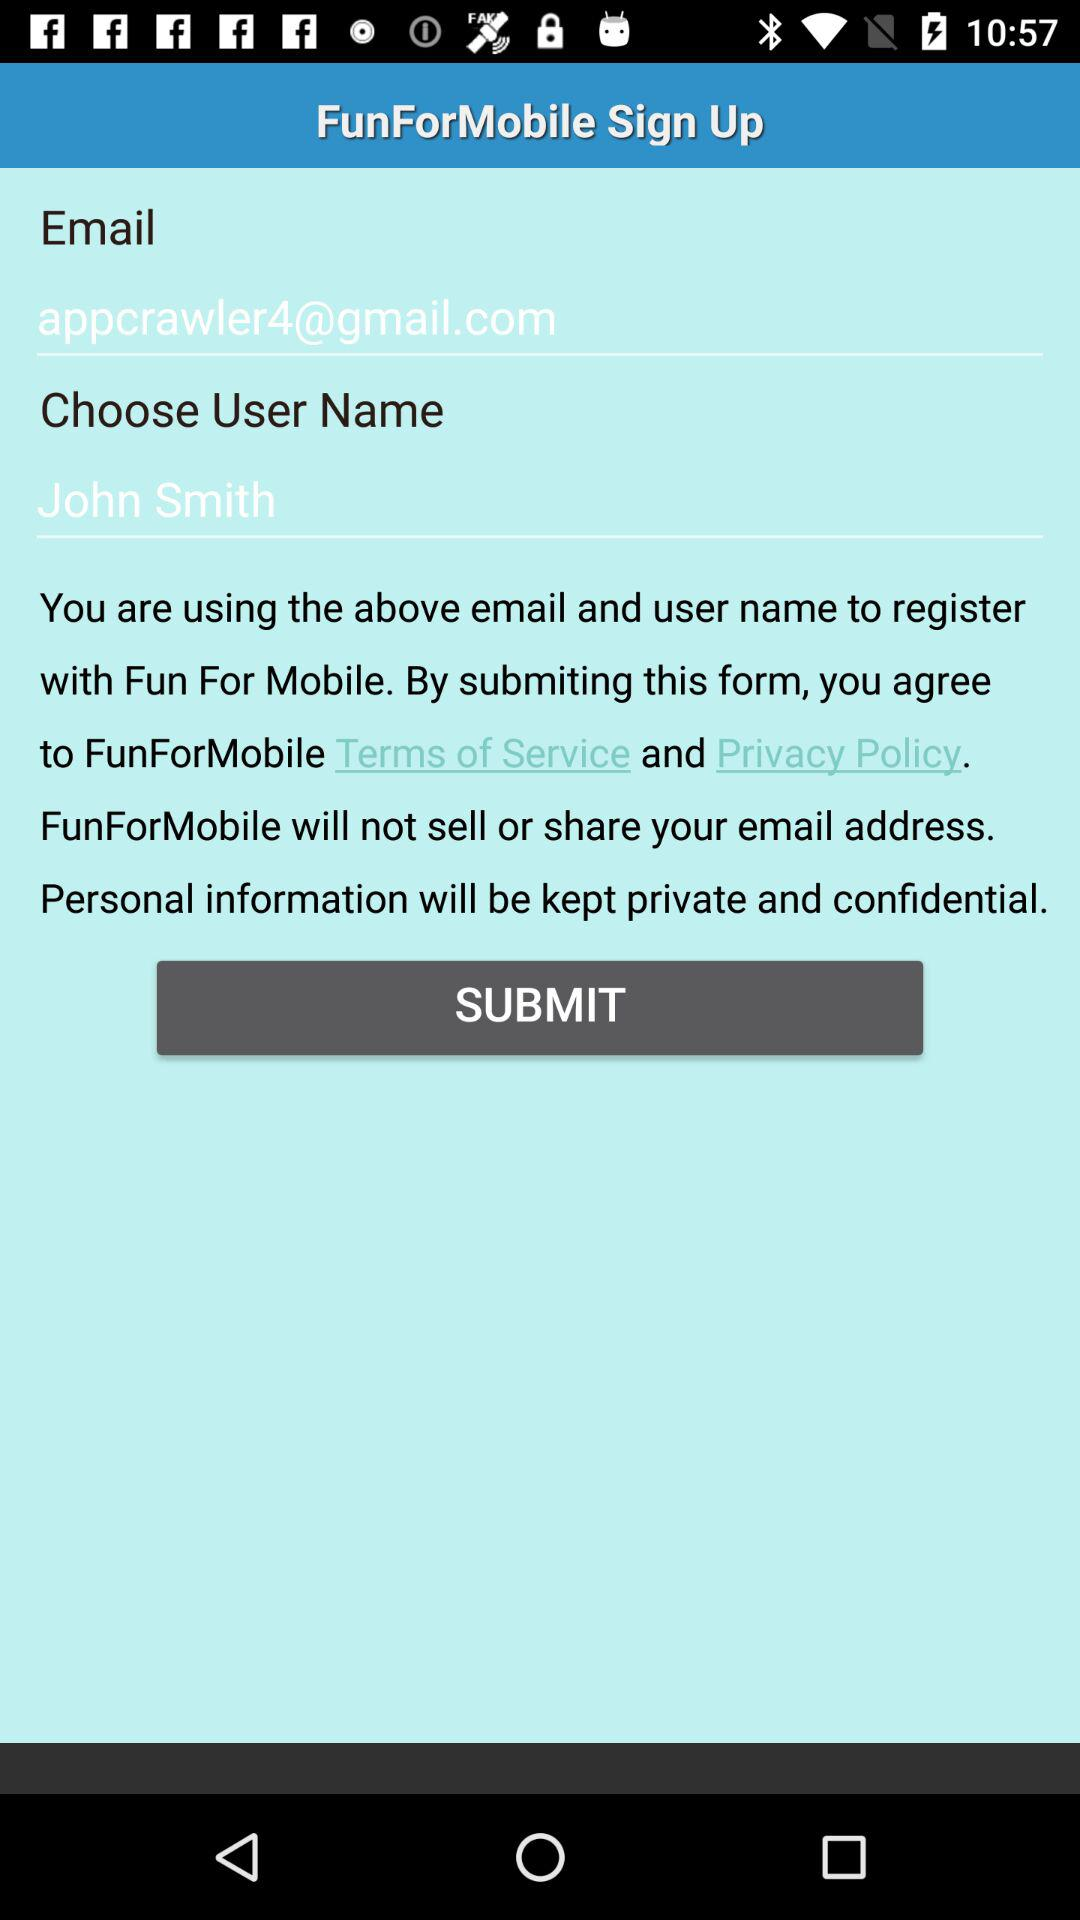What is the name of the user? The name of the user is "John Smith". 